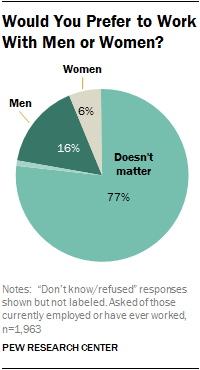Point out several critical features in this image. Men and women have different percentages of work performed in society, with women typically performing more domestic and caretaking tasks and men more paid labor. The segment for women is gray. 